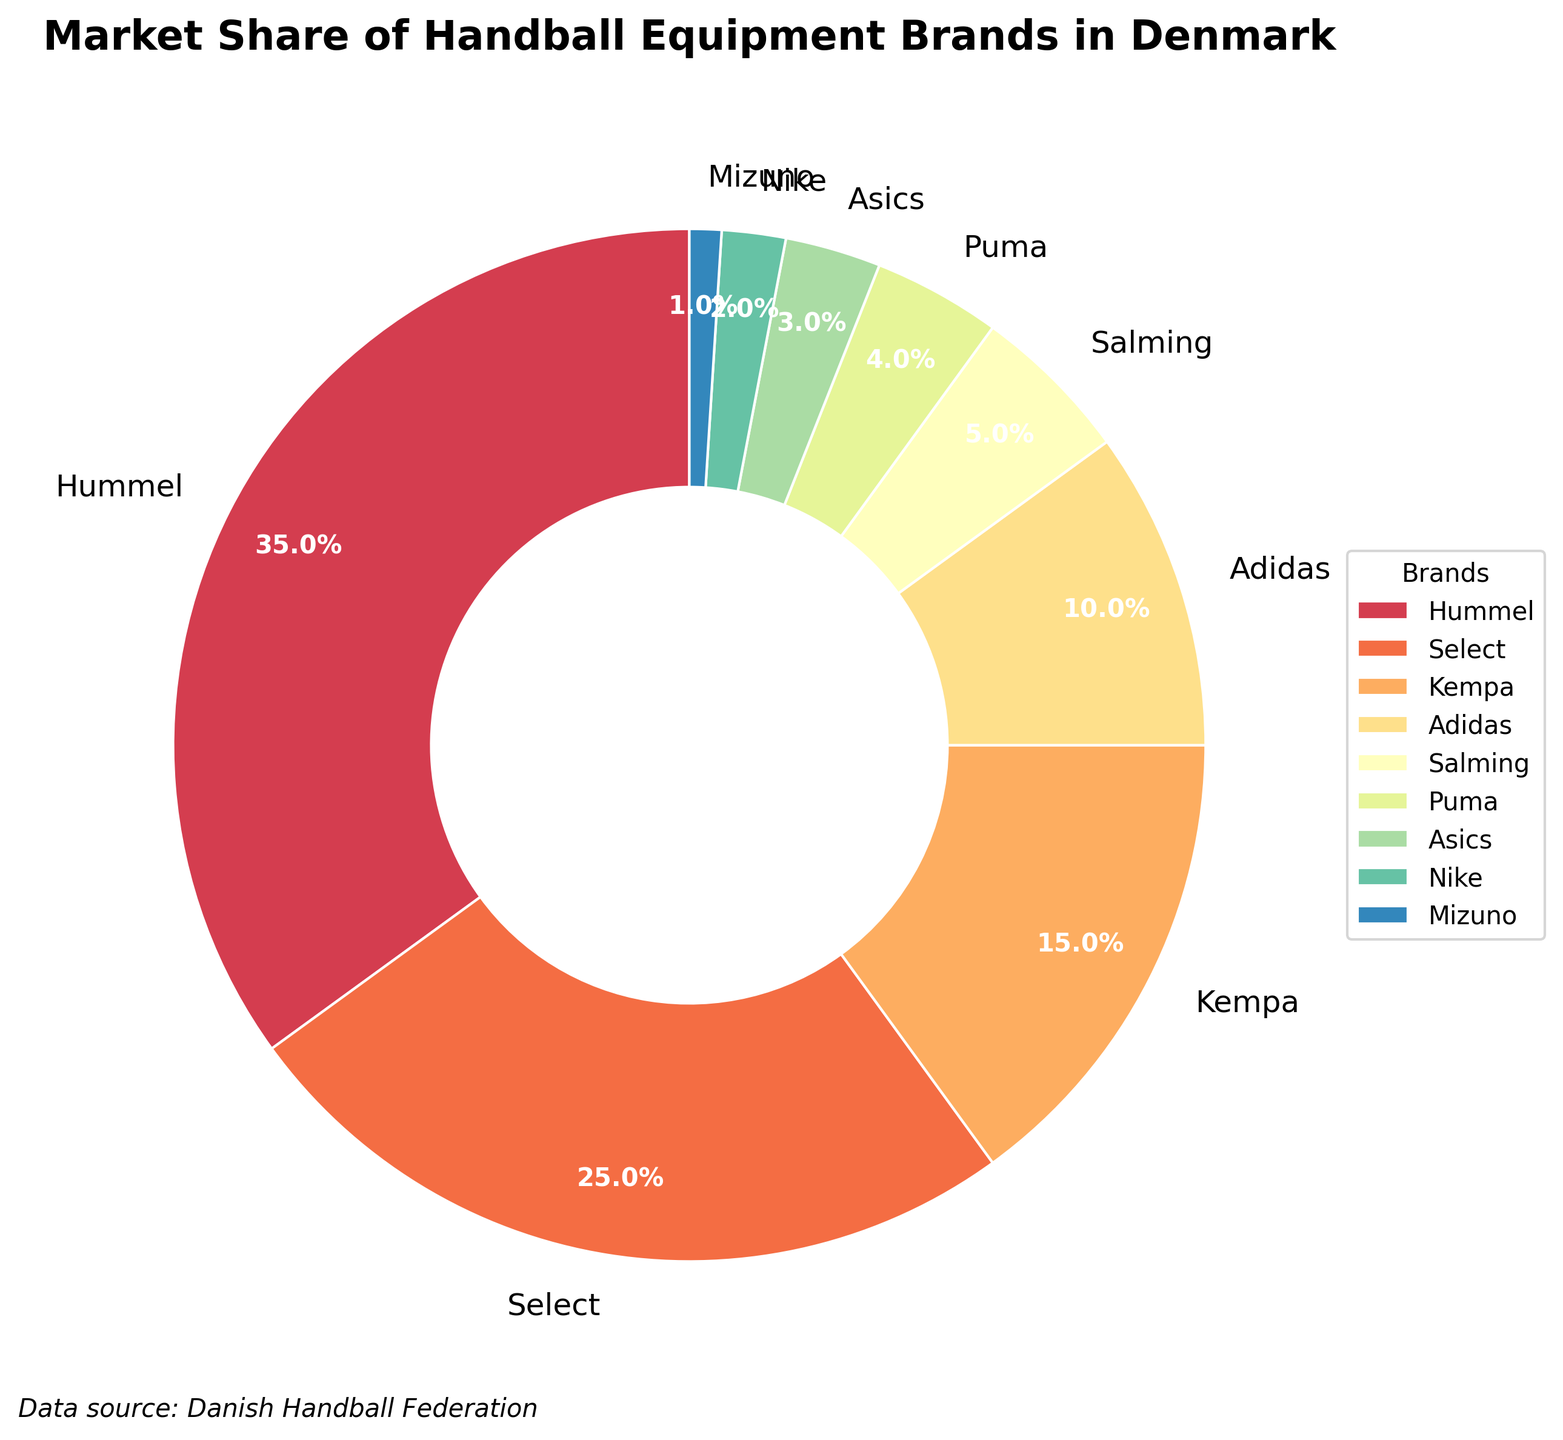Which brand has the highest market share? The brand with the highest market share can be identified directly by looking for the largest segment in the pie chart. According to the data, Hummel has the largest segment.
Answer: Hummel What is the total market share of Hummel and Select combined? Add up the market shares of Hummel and Select. Hummel has a market share of 35%, and Select has 25%. So, the total is 35% + 25% = 60%.
Answer: 60% Which brand has a smaller market share, Salming or Puma? By comparing the market shares of Salming (5%) and Puma (4%), we can see that Puma's market share is smaller.
Answer: Puma How much more market share does Adidas have compared to Nike? Subtract Nike's market share from Adidas's market share. Adidas has 10%, and Nike has 2%. So, the difference is 10% - 2% = 8%.
Answer: 8% What is the combined market share of the brands with less than 5% market share each? Identify the brands with less than 5% market share (Puma, Asics, Nike, and Mizuno). Sum their market shares: Puma (4%) + Asics (3%) + Nike (2%) + Mizuno (1%) = 10%.
Answer: 10% Rank the brands from highest to lowest market share. List the brands in descending order based on their market share: Hummel (35%), Select (25%), Kempa (15%), Adidas (10%), Salming (5%), Puma (4%), Asics (3%), Nike (2%), Mizuno (1%).
Answer: Hummel, Select, Kempa, Adidas, Salming, Puma, Asics, Nike, Mizuno How does the market share of Kempa compare to the combined market share of Asics and Nike? First, find the combined market share of Asics and Nike: 3% + 2% = 5%. Then compare it to Kempa's market share of 15%. Kempa's market share is greater.
Answer: Kempa’s market share is greater What percentage of the market share is held by brands with a market share above 10%? Identify the brands with more than 10% market share (Hummel, Select, and Kempa), and sum their market shares: Hummel (35%) + Select (25%) + Kempa (15%) = 75%.
Answer: 75% Which brand has the smallest market share, and what is it? Identify the brand with the smallest segment in the pie chart, which is Mizuno with 1%.
Answer: Mizuno, 1% How many brands have a market share of 10% or less? Identify all brands with a market share of 10% or less: Adidas (10%), Salming (5%), Puma (4%), Asics (3%), Nike (2%), Mizuno (1%). Count these brands: 6 brands.
Answer: 6 brands 